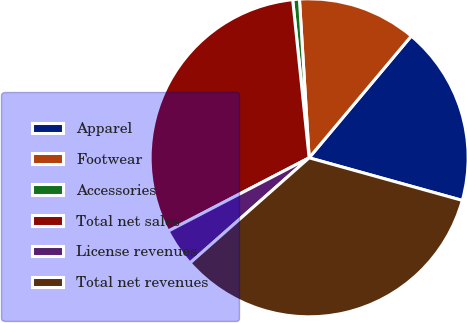Convert chart. <chart><loc_0><loc_0><loc_500><loc_500><pie_chart><fcel>Apparel<fcel>Footwear<fcel>Accessories<fcel>Total net sales<fcel>License revenues<fcel>Total net revenues<nl><fcel>18.21%<fcel>12.08%<fcel>0.68%<fcel>30.98%<fcel>3.88%<fcel>34.17%<nl></chart> 